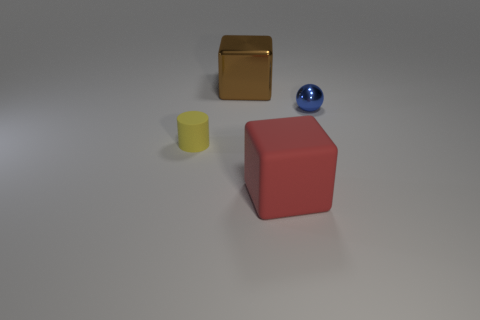Add 4 tiny balls. How many objects exist? 8 Subtract all cylinders. How many objects are left? 3 Add 1 large matte objects. How many large matte objects exist? 2 Subtract 0 gray blocks. How many objects are left? 4 Subtract all small purple rubber cylinders. Subtract all metal cubes. How many objects are left? 3 Add 2 tiny metallic balls. How many tiny metallic balls are left? 3 